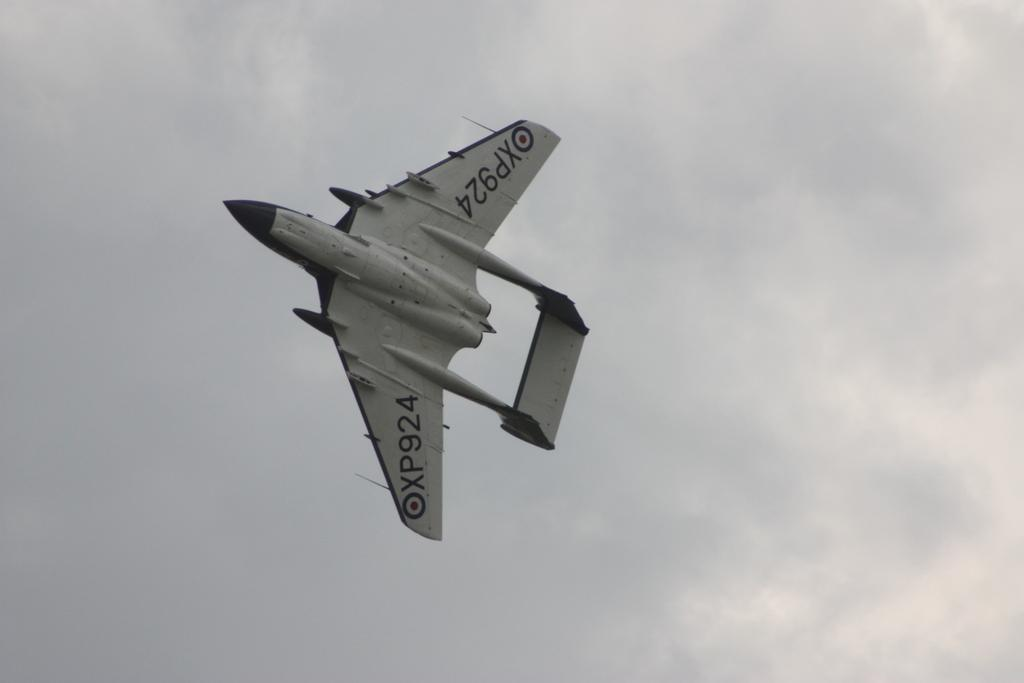<image>
Relay a brief, clear account of the picture shown. XP924 airplane taking flight in the sky near the clouds. 